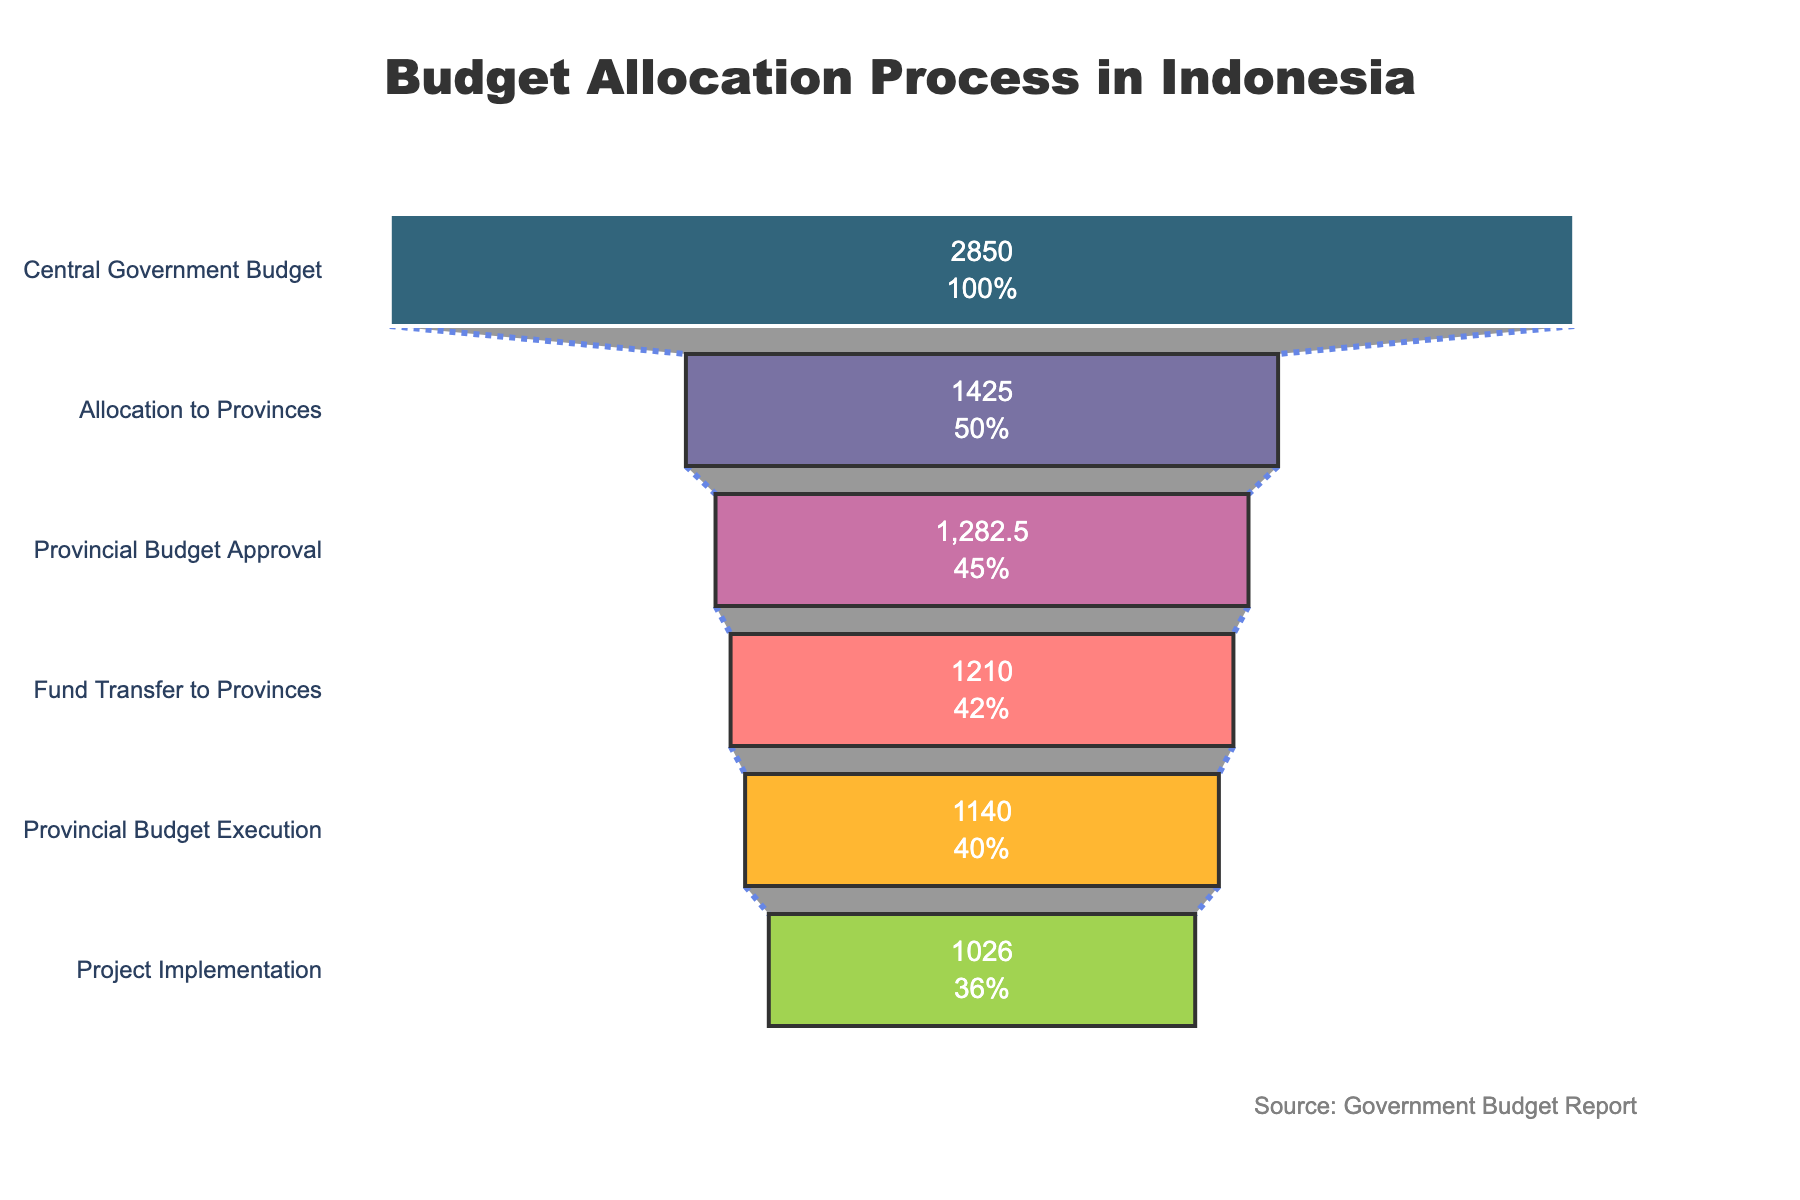What is the title of the funnel chart? The title of the funnel chart is written at the top of the figure. It provides a brief summary of the data being visualized.
Answer: Budget Allocation Process in Indonesia What is the amount allocated to provinces? The amount allocated to provinces is displayed on the funnel chart's 'Allocation to Provinces' stage.
Answer: 1425 Trillion IDR Which stage has the lowest budget allocation? To find the stage with the lowest budget allocation, look for the smallest value on the funnel chart.
Answer: Project Implementation How much budget is lost between the Allocation to Provinces and Provincial Budget Approval stages? Subtract the amount of the 'Provincial Budget Approval' stage from the 'Allocation to Provinces' stage. 1425 - 1282.5 = 142.5
Answer: 142.5 Trillion IDR What percentage of the initial central government budget reaches the Project Implementation stage? The percentage can be found in the 'Project Implementation' stage's percentage value relative to the 'Central Government Budget' stage.
Answer: 36% What is the ratio of the Provincial Budget Execution to Fund Transfer to Provinces? Divide the amount at the 'Provincial Budget Execution' stage by the amount at the 'Fund Transfer to Provinces' stage. 1140 / 1210 = ~0.942
Answer: ~0.942 How much budget is allocated from the Central Government Budget to the Project Implementation stage? Subtract the amount at the 'Project Implementation' stage from the 'Central Government Budget' stage. 2850 - 1026 = 1824
Answer: 1824 Trillion IDR What stage follows Provincial Budget Approval? This will be shown immediately below the 'Provincial Budget Approval' stage in the funnel chart.
Answer: Fund Transfer to Provinces Which stage shows the largest drop in IDR amount compared to its previous stage? Calculate the difference between consecutive stages and find the largest drop. The largest difference is between 'Central Government Budget' and 'Allocation to Provinces': 2850 - 1425 = 1425
Answer: Allocation to Provinces Between which stages does the budget drop from 1425 Trillion IDR to 1282.5 Trillion IDR? Look for the drop from 1425 Trillion IDR to 1282.5 Trillion IDR; this occurs between 'Allocation to Provinces' and 'Provincial Budget Approval'.
Answer: Allocation to Provinces and Provincial Budget Approval 